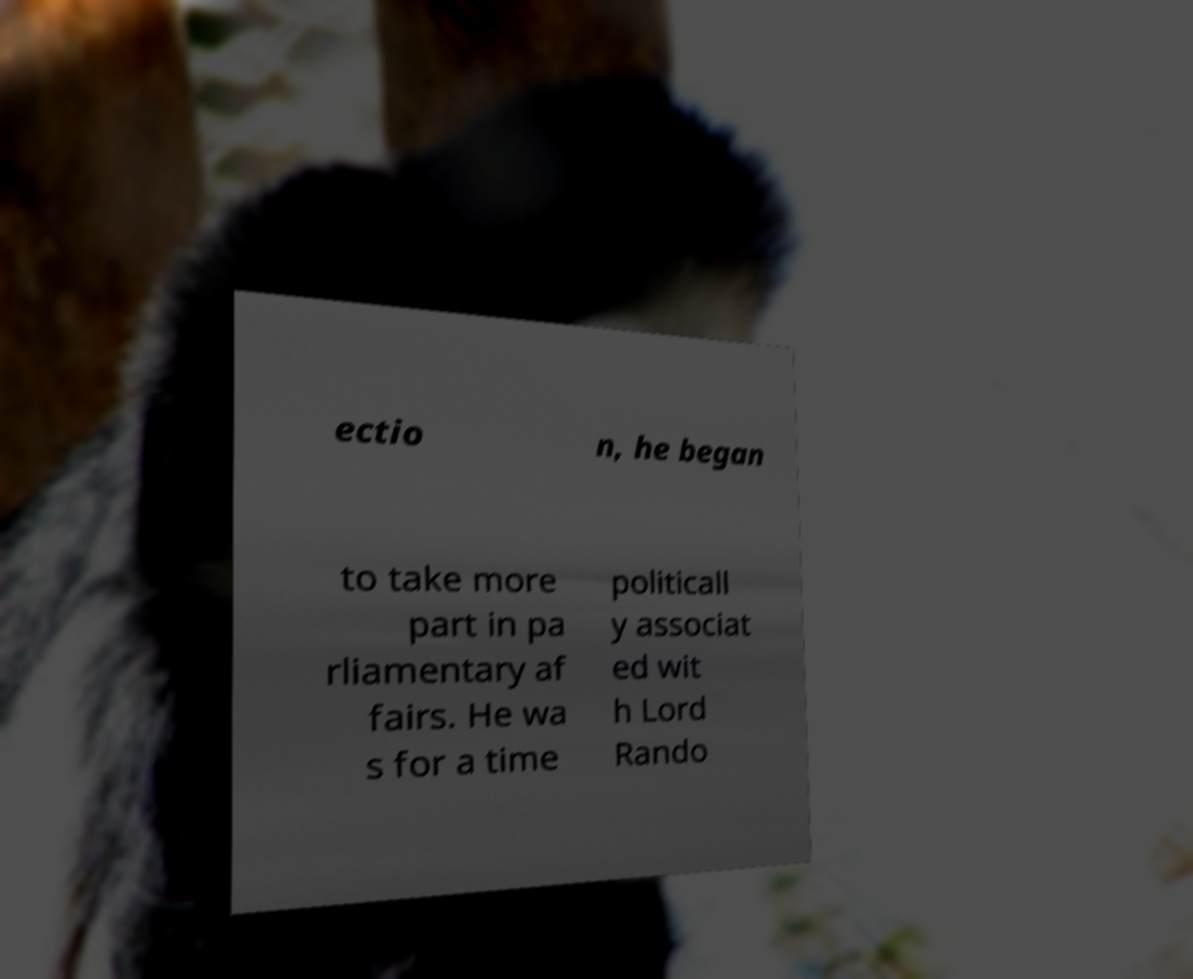Could you assist in decoding the text presented in this image and type it out clearly? ectio n, he began to take more part in pa rliamentary af fairs. He wa s for a time politicall y associat ed wit h Lord Rando 